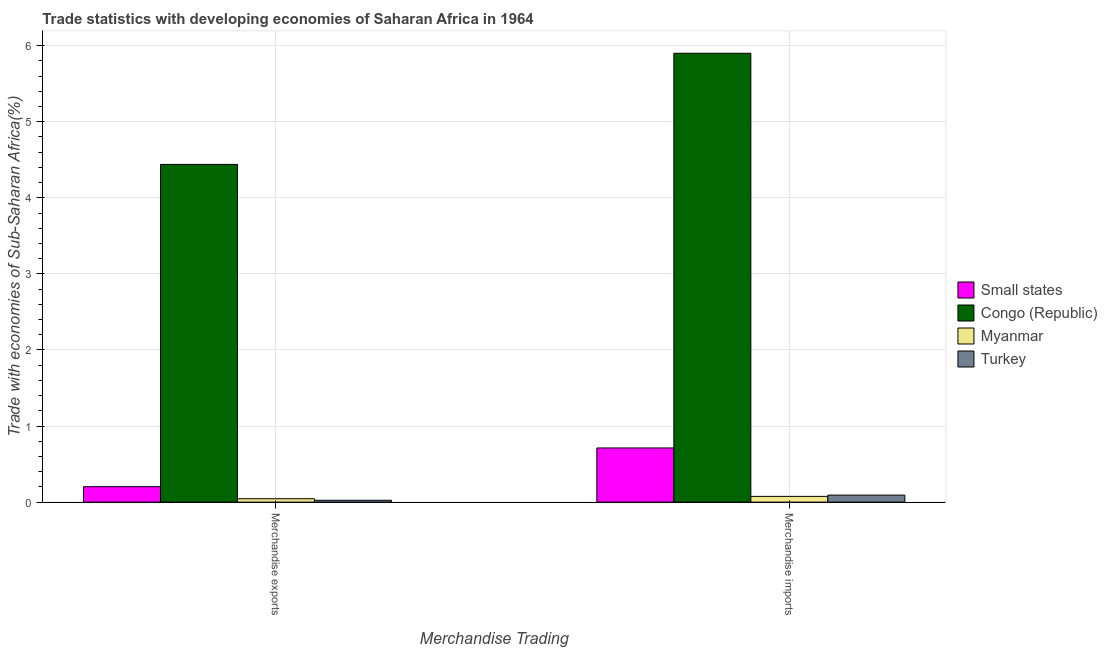Are the number of bars per tick equal to the number of legend labels?
Your answer should be very brief. Yes. Are the number of bars on each tick of the X-axis equal?
Your answer should be compact. Yes. What is the label of the 2nd group of bars from the left?
Your answer should be very brief. Merchandise imports. What is the merchandise imports in Myanmar?
Ensure brevity in your answer.  0.08. Across all countries, what is the maximum merchandise imports?
Make the answer very short. 5.9. Across all countries, what is the minimum merchandise exports?
Keep it short and to the point. 0.02. In which country was the merchandise imports maximum?
Ensure brevity in your answer.  Congo (Republic). What is the total merchandise imports in the graph?
Make the answer very short. 6.78. What is the difference between the merchandise exports in Congo (Republic) and that in Myanmar?
Your answer should be compact. 4.4. What is the difference between the merchandise exports in Myanmar and the merchandise imports in Small states?
Make the answer very short. -0.67. What is the average merchandise imports per country?
Offer a terse response. 1.7. What is the difference between the merchandise imports and merchandise exports in Turkey?
Provide a short and direct response. 0.07. What is the ratio of the merchandise imports in Turkey to that in Congo (Republic)?
Provide a succinct answer. 0.02. In how many countries, is the merchandise exports greater than the average merchandise exports taken over all countries?
Offer a very short reply. 1. What does the 2nd bar from the right in Merchandise exports represents?
Your response must be concise. Myanmar. How many bars are there?
Provide a short and direct response. 8. How many countries are there in the graph?
Keep it short and to the point. 4. Does the graph contain grids?
Provide a short and direct response. Yes. Where does the legend appear in the graph?
Offer a terse response. Center right. How many legend labels are there?
Provide a short and direct response. 4. What is the title of the graph?
Provide a short and direct response. Trade statistics with developing economies of Saharan Africa in 1964. Does "Pacific island small states" appear as one of the legend labels in the graph?
Your answer should be compact. No. What is the label or title of the X-axis?
Make the answer very short. Merchandise Trading. What is the label or title of the Y-axis?
Provide a short and direct response. Trade with economies of Sub-Saharan Africa(%). What is the Trade with economies of Sub-Saharan Africa(%) in Small states in Merchandise exports?
Keep it short and to the point. 0.2. What is the Trade with economies of Sub-Saharan Africa(%) in Congo (Republic) in Merchandise exports?
Your answer should be compact. 4.44. What is the Trade with economies of Sub-Saharan Africa(%) in Myanmar in Merchandise exports?
Provide a short and direct response. 0.04. What is the Trade with economies of Sub-Saharan Africa(%) in Turkey in Merchandise exports?
Provide a short and direct response. 0.02. What is the Trade with economies of Sub-Saharan Africa(%) in Small states in Merchandise imports?
Give a very brief answer. 0.71. What is the Trade with economies of Sub-Saharan Africa(%) of Congo (Republic) in Merchandise imports?
Your answer should be very brief. 5.9. What is the Trade with economies of Sub-Saharan Africa(%) in Myanmar in Merchandise imports?
Your answer should be compact. 0.08. What is the Trade with economies of Sub-Saharan Africa(%) of Turkey in Merchandise imports?
Keep it short and to the point. 0.09. Across all Merchandise Trading, what is the maximum Trade with economies of Sub-Saharan Africa(%) in Small states?
Offer a very short reply. 0.71. Across all Merchandise Trading, what is the maximum Trade with economies of Sub-Saharan Africa(%) of Congo (Republic)?
Offer a very short reply. 5.9. Across all Merchandise Trading, what is the maximum Trade with economies of Sub-Saharan Africa(%) in Myanmar?
Offer a very short reply. 0.08. Across all Merchandise Trading, what is the maximum Trade with economies of Sub-Saharan Africa(%) of Turkey?
Keep it short and to the point. 0.09. Across all Merchandise Trading, what is the minimum Trade with economies of Sub-Saharan Africa(%) of Small states?
Make the answer very short. 0.2. Across all Merchandise Trading, what is the minimum Trade with economies of Sub-Saharan Africa(%) in Congo (Republic)?
Ensure brevity in your answer.  4.44. Across all Merchandise Trading, what is the minimum Trade with economies of Sub-Saharan Africa(%) in Myanmar?
Your answer should be compact. 0.04. Across all Merchandise Trading, what is the minimum Trade with economies of Sub-Saharan Africa(%) in Turkey?
Provide a succinct answer. 0.02. What is the total Trade with economies of Sub-Saharan Africa(%) in Small states in the graph?
Offer a terse response. 0.92. What is the total Trade with economies of Sub-Saharan Africa(%) of Congo (Republic) in the graph?
Your answer should be compact. 10.34. What is the total Trade with economies of Sub-Saharan Africa(%) in Myanmar in the graph?
Provide a short and direct response. 0.12. What is the total Trade with economies of Sub-Saharan Africa(%) of Turkey in the graph?
Provide a succinct answer. 0.12. What is the difference between the Trade with economies of Sub-Saharan Africa(%) of Small states in Merchandise exports and that in Merchandise imports?
Provide a short and direct response. -0.51. What is the difference between the Trade with economies of Sub-Saharan Africa(%) of Congo (Republic) in Merchandise exports and that in Merchandise imports?
Make the answer very short. -1.46. What is the difference between the Trade with economies of Sub-Saharan Africa(%) of Myanmar in Merchandise exports and that in Merchandise imports?
Provide a short and direct response. -0.03. What is the difference between the Trade with economies of Sub-Saharan Africa(%) in Turkey in Merchandise exports and that in Merchandise imports?
Make the answer very short. -0.07. What is the difference between the Trade with economies of Sub-Saharan Africa(%) in Small states in Merchandise exports and the Trade with economies of Sub-Saharan Africa(%) in Congo (Republic) in Merchandise imports?
Keep it short and to the point. -5.7. What is the difference between the Trade with economies of Sub-Saharan Africa(%) in Small states in Merchandise exports and the Trade with economies of Sub-Saharan Africa(%) in Myanmar in Merchandise imports?
Provide a short and direct response. 0.13. What is the difference between the Trade with economies of Sub-Saharan Africa(%) of Small states in Merchandise exports and the Trade with economies of Sub-Saharan Africa(%) of Turkey in Merchandise imports?
Your answer should be compact. 0.11. What is the difference between the Trade with economies of Sub-Saharan Africa(%) in Congo (Republic) in Merchandise exports and the Trade with economies of Sub-Saharan Africa(%) in Myanmar in Merchandise imports?
Make the answer very short. 4.36. What is the difference between the Trade with economies of Sub-Saharan Africa(%) in Congo (Republic) in Merchandise exports and the Trade with economies of Sub-Saharan Africa(%) in Turkey in Merchandise imports?
Ensure brevity in your answer.  4.35. What is the difference between the Trade with economies of Sub-Saharan Africa(%) of Myanmar in Merchandise exports and the Trade with economies of Sub-Saharan Africa(%) of Turkey in Merchandise imports?
Ensure brevity in your answer.  -0.05. What is the average Trade with economies of Sub-Saharan Africa(%) in Small states per Merchandise Trading?
Your answer should be very brief. 0.46. What is the average Trade with economies of Sub-Saharan Africa(%) of Congo (Republic) per Merchandise Trading?
Your response must be concise. 5.17. What is the average Trade with economies of Sub-Saharan Africa(%) of Myanmar per Merchandise Trading?
Provide a succinct answer. 0.06. What is the average Trade with economies of Sub-Saharan Africa(%) of Turkey per Merchandise Trading?
Give a very brief answer. 0.06. What is the difference between the Trade with economies of Sub-Saharan Africa(%) in Small states and Trade with economies of Sub-Saharan Africa(%) in Congo (Republic) in Merchandise exports?
Ensure brevity in your answer.  -4.24. What is the difference between the Trade with economies of Sub-Saharan Africa(%) of Small states and Trade with economies of Sub-Saharan Africa(%) of Myanmar in Merchandise exports?
Offer a terse response. 0.16. What is the difference between the Trade with economies of Sub-Saharan Africa(%) in Small states and Trade with economies of Sub-Saharan Africa(%) in Turkey in Merchandise exports?
Offer a terse response. 0.18. What is the difference between the Trade with economies of Sub-Saharan Africa(%) in Congo (Republic) and Trade with economies of Sub-Saharan Africa(%) in Myanmar in Merchandise exports?
Provide a succinct answer. 4.39. What is the difference between the Trade with economies of Sub-Saharan Africa(%) in Congo (Republic) and Trade with economies of Sub-Saharan Africa(%) in Turkey in Merchandise exports?
Give a very brief answer. 4.42. What is the difference between the Trade with economies of Sub-Saharan Africa(%) of Myanmar and Trade with economies of Sub-Saharan Africa(%) of Turkey in Merchandise exports?
Your answer should be compact. 0.02. What is the difference between the Trade with economies of Sub-Saharan Africa(%) in Small states and Trade with economies of Sub-Saharan Africa(%) in Congo (Republic) in Merchandise imports?
Give a very brief answer. -5.19. What is the difference between the Trade with economies of Sub-Saharan Africa(%) in Small states and Trade with economies of Sub-Saharan Africa(%) in Myanmar in Merchandise imports?
Provide a short and direct response. 0.64. What is the difference between the Trade with economies of Sub-Saharan Africa(%) of Small states and Trade with economies of Sub-Saharan Africa(%) of Turkey in Merchandise imports?
Your response must be concise. 0.62. What is the difference between the Trade with economies of Sub-Saharan Africa(%) of Congo (Republic) and Trade with economies of Sub-Saharan Africa(%) of Myanmar in Merchandise imports?
Your answer should be compact. 5.83. What is the difference between the Trade with economies of Sub-Saharan Africa(%) of Congo (Republic) and Trade with economies of Sub-Saharan Africa(%) of Turkey in Merchandise imports?
Provide a succinct answer. 5.81. What is the difference between the Trade with economies of Sub-Saharan Africa(%) of Myanmar and Trade with economies of Sub-Saharan Africa(%) of Turkey in Merchandise imports?
Make the answer very short. -0.02. What is the ratio of the Trade with economies of Sub-Saharan Africa(%) of Small states in Merchandise exports to that in Merchandise imports?
Give a very brief answer. 0.29. What is the ratio of the Trade with economies of Sub-Saharan Africa(%) of Congo (Republic) in Merchandise exports to that in Merchandise imports?
Your answer should be very brief. 0.75. What is the ratio of the Trade with economies of Sub-Saharan Africa(%) of Myanmar in Merchandise exports to that in Merchandise imports?
Your answer should be compact. 0.59. What is the ratio of the Trade with economies of Sub-Saharan Africa(%) of Turkey in Merchandise exports to that in Merchandise imports?
Provide a succinct answer. 0.26. What is the difference between the highest and the second highest Trade with economies of Sub-Saharan Africa(%) in Small states?
Give a very brief answer. 0.51. What is the difference between the highest and the second highest Trade with economies of Sub-Saharan Africa(%) in Congo (Republic)?
Give a very brief answer. 1.46. What is the difference between the highest and the second highest Trade with economies of Sub-Saharan Africa(%) of Myanmar?
Keep it short and to the point. 0.03. What is the difference between the highest and the second highest Trade with economies of Sub-Saharan Africa(%) of Turkey?
Ensure brevity in your answer.  0.07. What is the difference between the highest and the lowest Trade with economies of Sub-Saharan Africa(%) in Small states?
Ensure brevity in your answer.  0.51. What is the difference between the highest and the lowest Trade with economies of Sub-Saharan Africa(%) of Congo (Republic)?
Provide a succinct answer. 1.46. What is the difference between the highest and the lowest Trade with economies of Sub-Saharan Africa(%) of Myanmar?
Your answer should be compact. 0.03. What is the difference between the highest and the lowest Trade with economies of Sub-Saharan Africa(%) in Turkey?
Give a very brief answer. 0.07. 